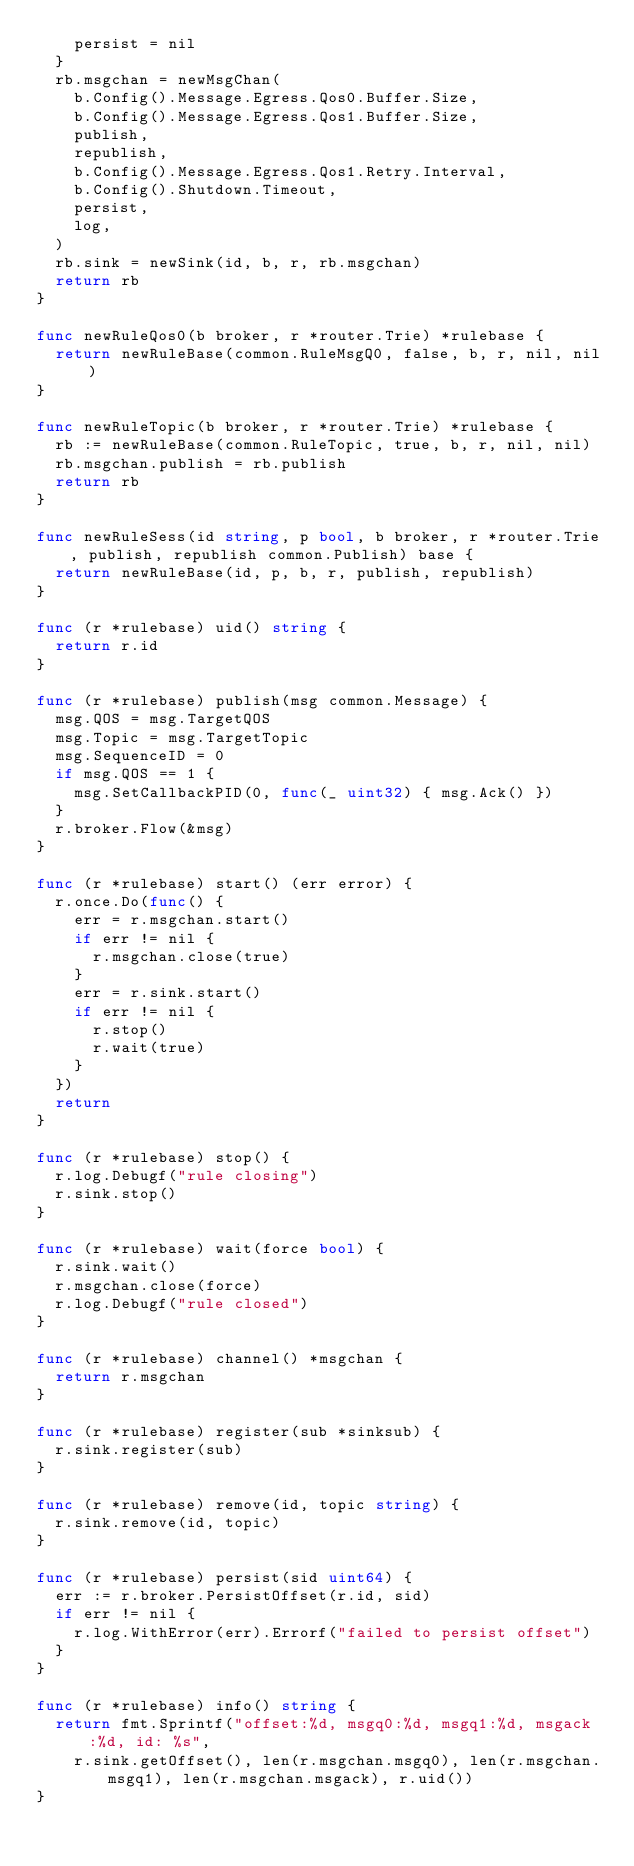<code> <loc_0><loc_0><loc_500><loc_500><_Go_>		persist = nil
	}
	rb.msgchan = newMsgChan(
		b.Config().Message.Egress.Qos0.Buffer.Size,
		b.Config().Message.Egress.Qos1.Buffer.Size,
		publish,
		republish,
		b.Config().Message.Egress.Qos1.Retry.Interval,
		b.Config().Shutdown.Timeout,
		persist,
		log,
	)
	rb.sink = newSink(id, b, r, rb.msgchan)
	return rb
}

func newRuleQos0(b broker, r *router.Trie) *rulebase {
	return newRuleBase(common.RuleMsgQ0, false, b, r, nil, nil)
}

func newRuleTopic(b broker, r *router.Trie) *rulebase {
	rb := newRuleBase(common.RuleTopic, true, b, r, nil, nil)
	rb.msgchan.publish = rb.publish
	return rb
}

func newRuleSess(id string, p bool, b broker, r *router.Trie, publish, republish common.Publish) base {
	return newRuleBase(id, p, b, r, publish, republish)
}

func (r *rulebase) uid() string {
	return r.id
}

func (r *rulebase) publish(msg common.Message) {
	msg.QOS = msg.TargetQOS
	msg.Topic = msg.TargetTopic
	msg.SequenceID = 0
	if msg.QOS == 1 {
		msg.SetCallbackPID(0, func(_ uint32) { msg.Ack() })
	}
	r.broker.Flow(&msg)
}

func (r *rulebase) start() (err error) {
	r.once.Do(func() {
		err = r.msgchan.start()
		if err != nil {
			r.msgchan.close(true)
		}
		err = r.sink.start()
		if err != nil {
			r.stop()
			r.wait(true)
		}
	})
	return
}

func (r *rulebase) stop() {
	r.log.Debugf("rule closing")
	r.sink.stop()
}

func (r *rulebase) wait(force bool) {
	r.sink.wait()
	r.msgchan.close(force)
	r.log.Debugf("rule closed")
}

func (r *rulebase) channel() *msgchan {
	return r.msgchan
}

func (r *rulebase) register(sub *sinksub) {
	r.sink.register(sub)
}

func (r *rulebase) remove(id, topic string) {
	r.sink.remove(id, topic)
}

func (r *rulebase) persist(sid uint64) {
	err := r.broker.PersistOffset(r.id, sid)
	if err != nil {
		r.log.WithError(err).Errorf("failed to persist offset")
	}
}

func (r *rulebase) info() string {
	return fmt.Sprintf("offset:%d, msgq0:%d, msgq1:%d, msgack:%d, id: %s",
		r.sink.getOffset(), len(r.msgchan.msgq0), len(r.msgchan.msgq1), len(r.msgchan.msgack), r.uid())
}
</code> 